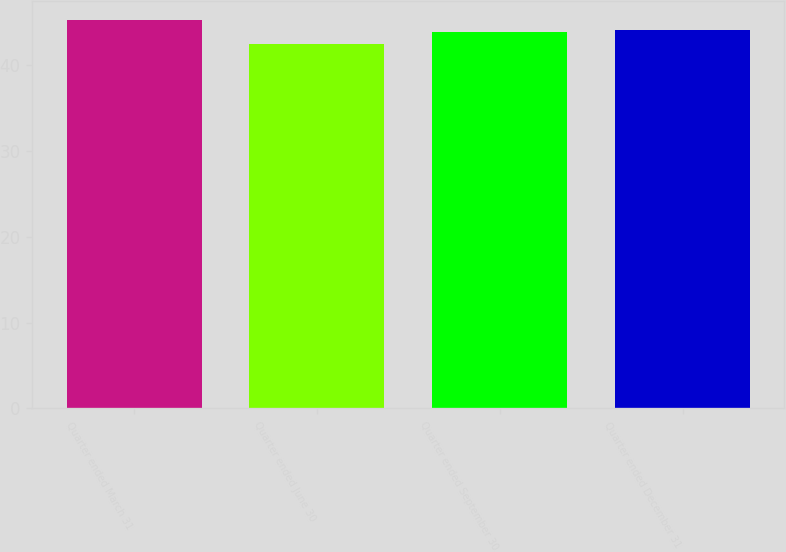<chart> <loc_0><loc_0><loc_500><loc_500><bar_chart><fcel>Quarter ended March 31<fcel>Quarter ended June 30<fcel>Quarter ended September 30<fcel>Quarter ended December 31<nl><fcel>45.2<fcel>42.45<fcel>43.8<fcel>44.07<nl></chart> 